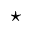<formula> <loc_0><loc_0><loc_500><loc_500>^ { * }</formula> 